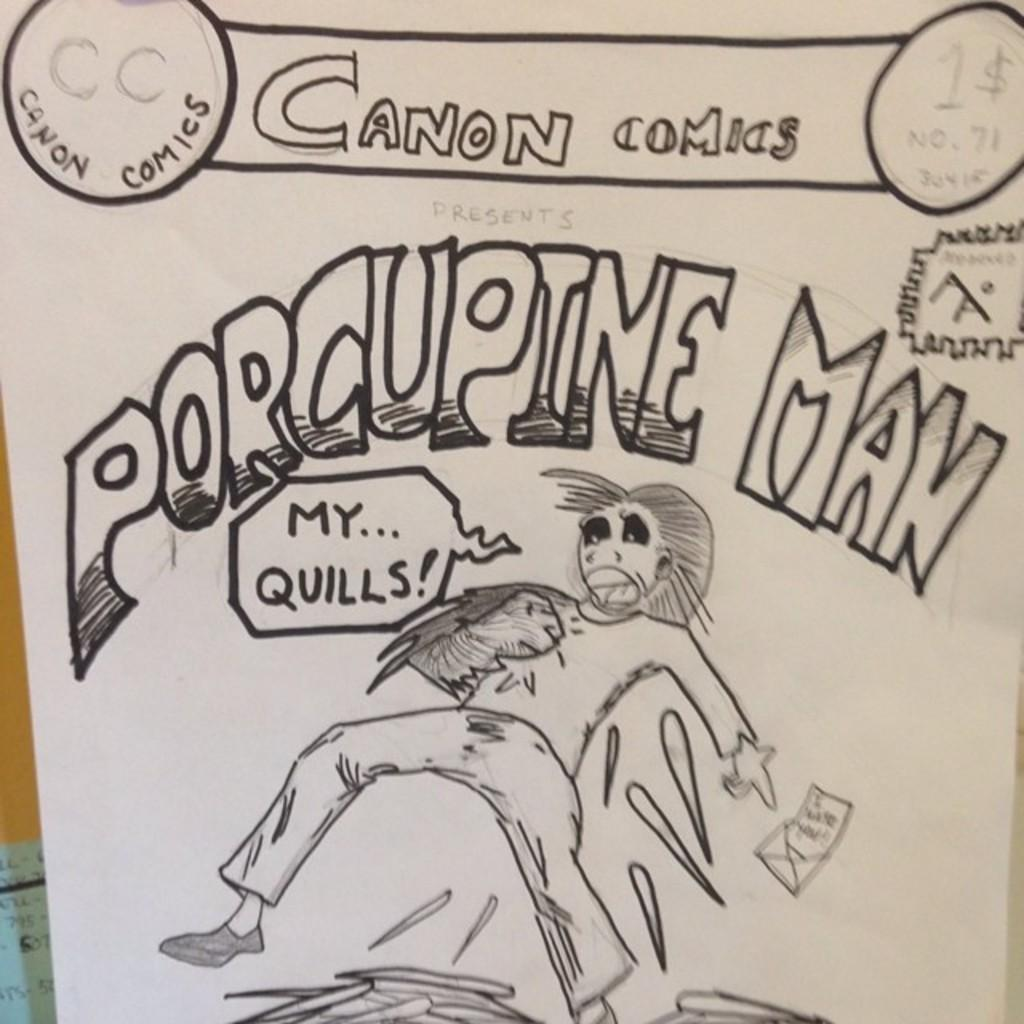What is the main subject in the foreground of the image? There is a sketch of a person in the foreground of the image. What else can be seen on the paper in the image? There is text at the top of the paper in the image. What type of good-bye message is written by the fireman in the image? There is no fireman or good-bye message present in the image. Is the person in the sketch a crook, and if so, what crime are they committing? The facts provided do not mention any crime or criminal activity, nor do they suggest that the person in the sketch is a crook. 